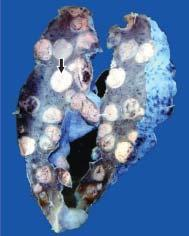what are large parts of the lung parenchyma replaced by?
Answer the question using a single word or phrase. Multiple 